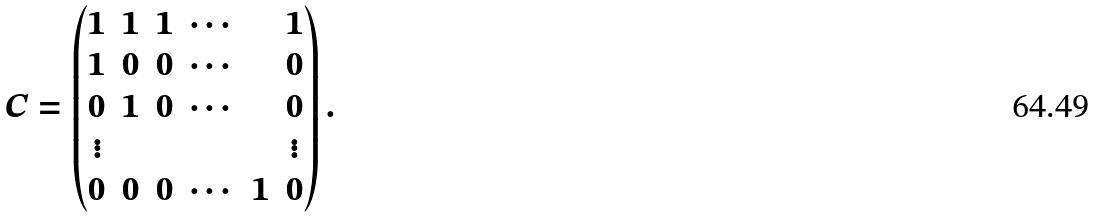<formula> <loc_0><loc_0><loc_500><loc_500>C = \begin{pmatrix} 1 & 1 & 1 & \cdots & & 1 \\ 1 & 0 & 0 & \cdots & & 0 \\ 0 & 1 & 0 & \cdots & & 0 \\ \vdots & & & & & \vdots \\ 0 & 0 & 0 & \cdots & 1 & 0 \\ \end{pmatrix} .</formula> 